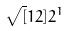<formula> <loc_0><loc_0><loc_500><loc_500>\sqrt { [ } 1 2 ] { 2 ^ { 1 } }</formula> 